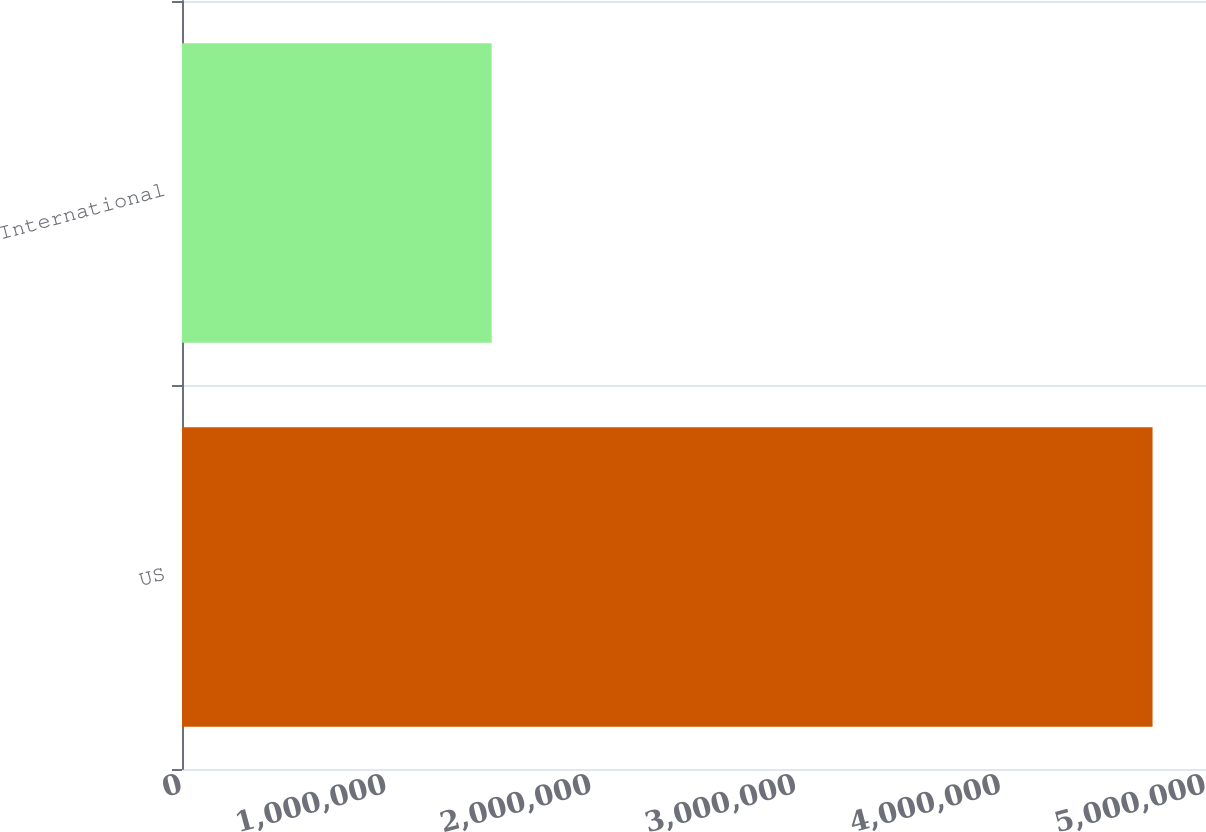Convert chart to OTSL. <chart><loc_0><loc_0><loc_500><loc_500><bar_chart><fcel>US<fcel>International<nl><fcel>4.739e+06<fcel>1.512e+06<nl></chart> 